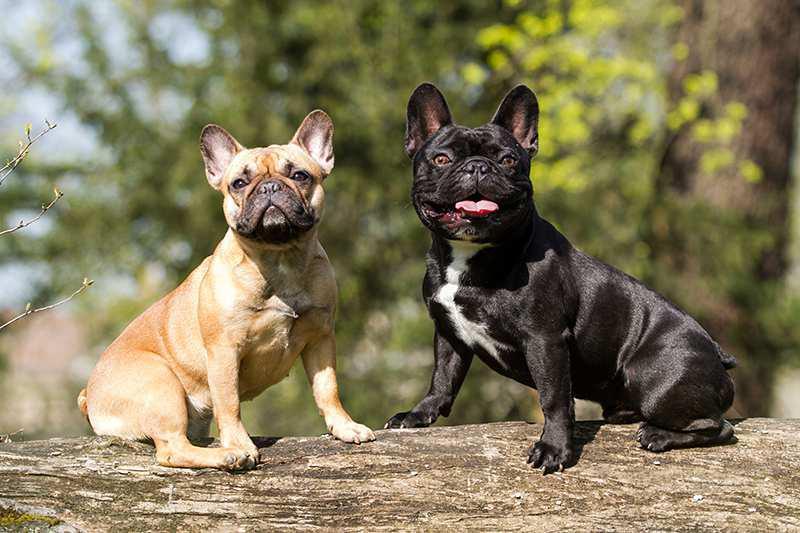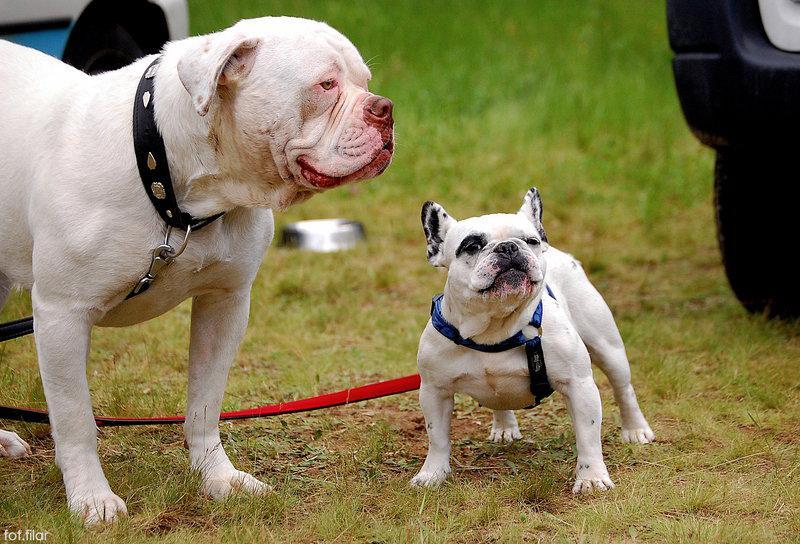The first image is the image on the left, the second image is the image on the right. Evaluate the accuracy of this statement regarding the images: "The left image contains exactly two dogs.". Is it true? Answer yes or no. Yes. The first image is the image on the left, the second image is the image on the right. Given the left and right images, does the statement "In one image, a dog has its paw resting on top of a ball" hold true? Answer yes or no. No. 